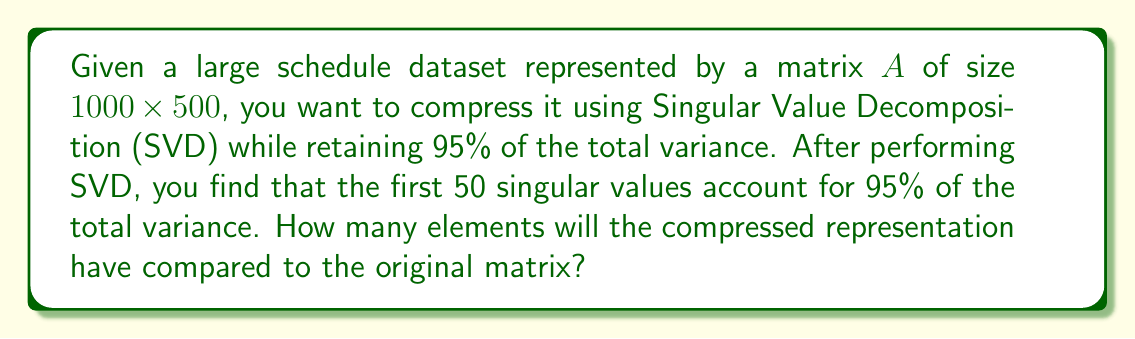Could you help me with this problem? Let's approach this step-by-step:

1) The original matrix $A$ has dimensions $1000 \times 500$, so it contains $1000 \times 500 = 500,000$ elements.

2) In SVD, matrix $A$ is decomposed as $A = U\Sigma V^T$, where:
   - $U$ is a $1000 \times 1000$ orthogonal matrix
   - $\Sigma$ is a $1000 \times 500$ diagonal matrix of singular values
   - $V^T$ is the transpose of a $500 \times 500$ orthogonal matrix

3) To compress the data while retaining 95% of the variance, we keep only the first 50 singular values and their corresponding singular vectors.

4) The compressed representation will consist of:
   - First 50 columns of $U$: $1000 \times 50 = 50,000$ elements
   - First 50 singular values: $50$ elements
   - First 50 rows of $V^T$ (or columns of $V$): $500 \times 50 = 25,000$ elements

5) Total elements in the compressed representation:
   $50,000 + 50 + 25,000 = 75,050$

6) To compare with the original matrix:
   $\frac{75,050}{500,000} \times 100 \approx 15.01\%$

Thus, the compressed representation contains approximately 15.01% of the elements in the original matrix.
Answer: 75,050 elements (15.01% of original) 